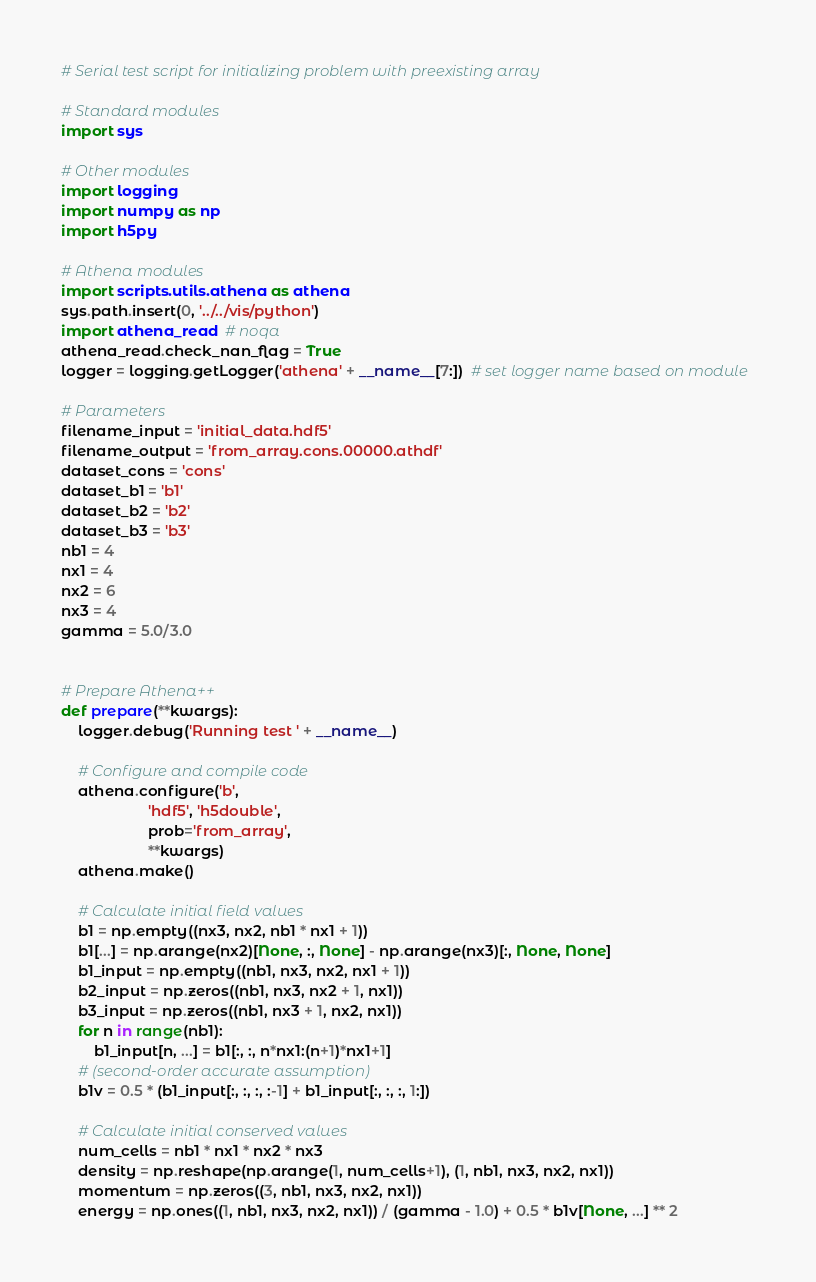Convert code to text. <code><loc_0><loc_0><loc_500><loc_500><_Python_># Serial test script for initializing problem with preexisting array

# Standard modules
import sys

# Other modules
import logging
import numpy as np
import h5py

# Athena modules
import scripts.utils.athena as athena
sys.path.insert(0, '../../vis/python')
import athena_read  # noqa
athena_read.check_nan_flag = True
logger = logging.getLogger('athena' + __name__[7:])  # set logger name based on module

# Parameters
filename_input = 'initial_data.hdf5'
filename_output = 'from_array.cons.00000.athdf'
dataset_cons = 'cons'
dataset_b1 = 'b1'
dataset_b2 = 'b2'
dataset_b3 = 'b3'
nb1 = 4
nx1 = 4
nx2 = 6
nx3 = 4
gamma = 5.0/3.0


# Prepare Athena++
def prepare(**kwargs):
    logger.debug('Running test ' + __name__)

    # Configure and compile code
    athena.configure('b',
                     'hdf5', 'h5double',
                     prob='from_array',
                     **kwargs)
    athena.make()

    # Calculate initial field values
    b1 = np.empty((nx3, nx2, nb1 * nx1 + 1))
    b1[...] = np.arange(nx2)[None, :, None] - np.arange(nx3)[:, None, None]
    b1_input = np.empty((nb1, nx3, nx2, nx1 + 1))
    b2_input = np.zeros((nb1, nx3, nx2 + 1, nx1))
    b3_input = np.zeros((nb1, nx3 + 1, nx2, nx1))
    for n in range(nb1):
        b1_input[n, ...] = b1[:, :, n*nx1:(n+1)*nx1+1]
    # (second-order accurate assumption)
    b1v = 0.5 * (b1_input[:, :, :, :-1] + b1_input[:, :, :, 1:])

    # Calculate initial conserved values
    num_cells = nb1 * nx1 * nx2 * nx3
    density = np.reshape(np.arange(1, num_cells+1), (1, nb1, nx3, nx2, nx1))
    momentum = np.zeros((3, nb1, nx3, nx2, nx1))
    energy = np.ones((1, nb1, nx3, nx2, nx1)) / (gamma - 1.0) + 0.5 * b1v[None, ...] ** 2</code> 